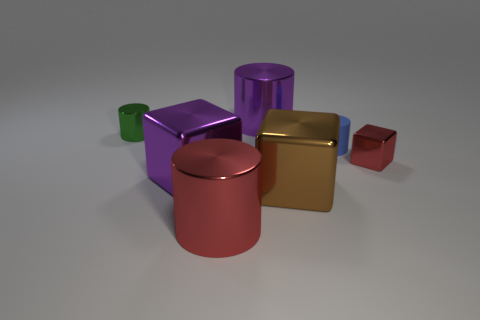There is a large object that is the same color as the tiny shiny block; what material is it?
Provide a succinct answer. Metal. There is another small cylinder that is the same material as the red cylinder; what is its color?
Your response must be concise. Green. Is there a purple cylinder that has the same size as the purple cube?
Your answer should be compact. Yes. What material is the other small thing that is the same shape as the tiny green metal object?
Make the answer very short. Rubber. What is the shape of the purple metallic object that is the same size as the purple shiny block?
Offer a terse response. Cylinder. Is there a tiny shiny object of the same shape as the tiny blue rubber thing?
Make the answer very short. Yes. What shape is the big purple metal thing behind the large purple metal object in front of the blue matte cylinder?
Your answer should be very brief. Cylinder. What is the shape of the big red object?
Offer a very short reply. Cylinder. What is the material of the purple thing behind the matte cylinder that is in front of the green metallic cylinder behind the small cube?
Keep it short and to the point. Metal. How many other objects are the same material as the tiny green object?
Your answer should be compact. 5. 